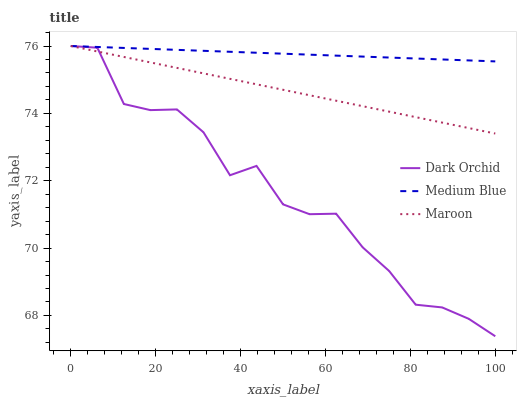Does Dark Orchid have the minimum area under the curve?
Answer yes or no. Yes. Does Medium Blue have the maximum area under the curve?
Answer yes or no. Yes. Does Maroon have the minimum area under the curve?
Answer yes or no. No. Does Maroon have the maximum area under the curve?
Answer yes or no. No. Is Maroon the smoothest?
Answer yes or no. Yes. Is Dark Orchid the roughest?
Answer yes or no. Yes. Is Dark Orchid the smoothest?
Answer yes or no. No. Is Maroon the roughest?
Answer yes or no. No. Does Dark Orchid have the lowest value?
Answer yes or no. Yes. Does Maroon have the lowest value?
Answer yes or no. No. Does Dark Orchid have the highest value?
Answer yes or no. Yes. Does Maroon intersect Dark Orchid?
Answer yes or no. Yes. Is Maroon less than Dark Orchid?
Answer yes or no. No. Is Maroon greater than Dark Orchid?
Answer yes or no. No. 